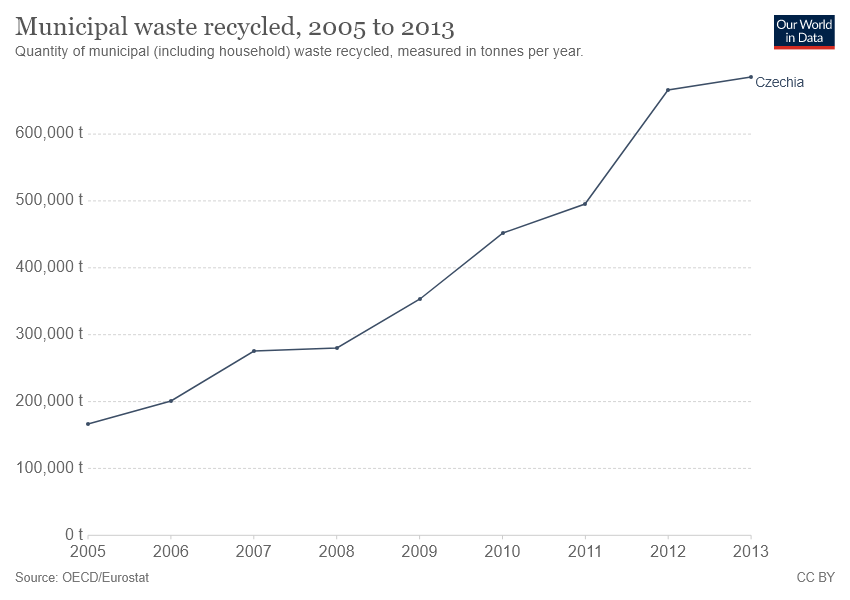Outline some significant characteristics in this image. According to data from 2005, the lowest level of municipal waste recycling in the Czech Republic was recorded. The difference between the two measures was higher in the years [2011, 2012]. 